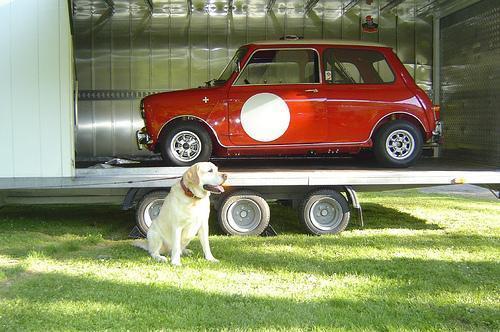How many dogs are in the picture?
Give a very brief answer. 1. How many dogs are there?
Give a very brief answer. 1. 